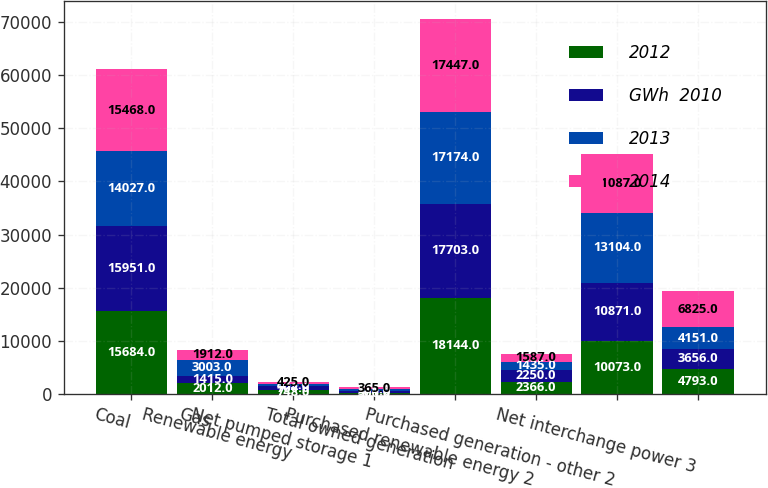<chart> <loc_0><loc_0><loc_500><loc_500><stacked_bar_chart><ecel><fcel>Coal<fcel>Gas<fcel>Renewable energy<fcel>Net pumped storage 1<fcel>Total owned generation<fcel>Purchased renewable energy 2<fcel>Purchased generation - other 2<fcel>Net interchange power 3<nl><fcel>2012<fcel>15684<fcel>2012<fcel>748<fcel>300<fcel>18144<fcel>2366<fcel>10073<fcel>4793<nl><fcel>GWh  2010<fcel>15951<fcel>1415<fcel>704<fcel>371<fcel>17703<fcel>2250<fcel>10871<fcel>3656<nl><fcel>2013<fcel>14027<fcel>3003<fcel>433<fcel>295<fcel>17174<fcel>1435<fcel>13104<fcel>4151<nl><fcel>2014<fcel>15468<fcel>1912<fcel>425<fcel>365<fcel>17447<fcel>1587<fcel>11087<fcel>6825<nl></chart> 